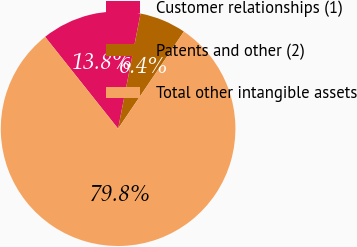<chart> <loc_0><loc_0><loc_500><loc_500><pie_chart><fcel>Customer relationships (1)<fcel>Patents and other (2)<fcel>Total other intangible assets<nl><fcel>13.75%<fcel>6.41%<fcel>79.84%<nl></chart> 